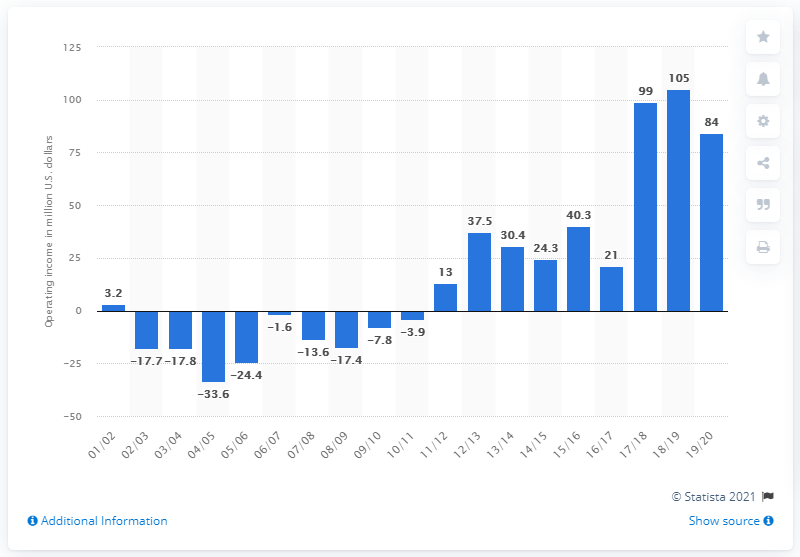Outline some significant characteristics in this image. The operating income of the Dallas Mavericks in the 2019/20 season was 84. 